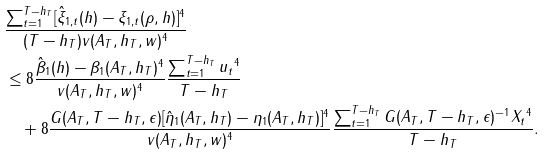Convert formula to latex. <formula><loc_0><loc_0><loc_500><loc_500>& \frac { \sum _ { t = 1 } ^ { T - h _ { T } } [ \hat { \xi } _ { 1 , t } ( h ) - \xi _ { 1 , t } ( \rho , h ) ] ^ { 4 } } { ( T - h _ { T } ) v ( A _ { T } , h _ { T } , w ) ^ { 4 } } \\ & \leq 8 \frac { \| \hat { \beta } _ { 1 } ( h ) - \beta _ { 1 } ( A _ { T } , h _ { T } ) \| ^ { 4 } } { v ( A _ { T } , h _ { T } , w ) ^ { 4 } } \frac { \sum _ { t = 1 } ^ { T - h _ { T } } \| u _ { t } \| ^ { 4 } } { T - h _ { T } } \\ & \quad + 8 \frac { \| G ( A _ { T } , T - h _ { T } , \epsilon ) [ \hat { \eta } _ { 1 } ( A _ { T } , h _ { T } ) - \eta _ { 1 } ( A _ { T } , h _ { T } ) ] \| ^ { 4 } } { v ( A _ { T } , h _ { T } , w ) ^ { 4 } } \frac { \sum _ { t = 1 } ^ { T - h _ { T } } \| G ( A _ { T } , T - h _ { T } , \epsilon ) ^ { - 1 } X _ { t } \| ^ { 4 } } { T - h _ { T } } .</formula> 